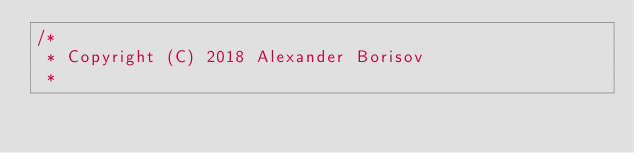<code> <loc_0><loc_0><loc_500><loc_500><_C_>/*
 * Copyright (C) 2018 Alexander Borisov
 *</code> 